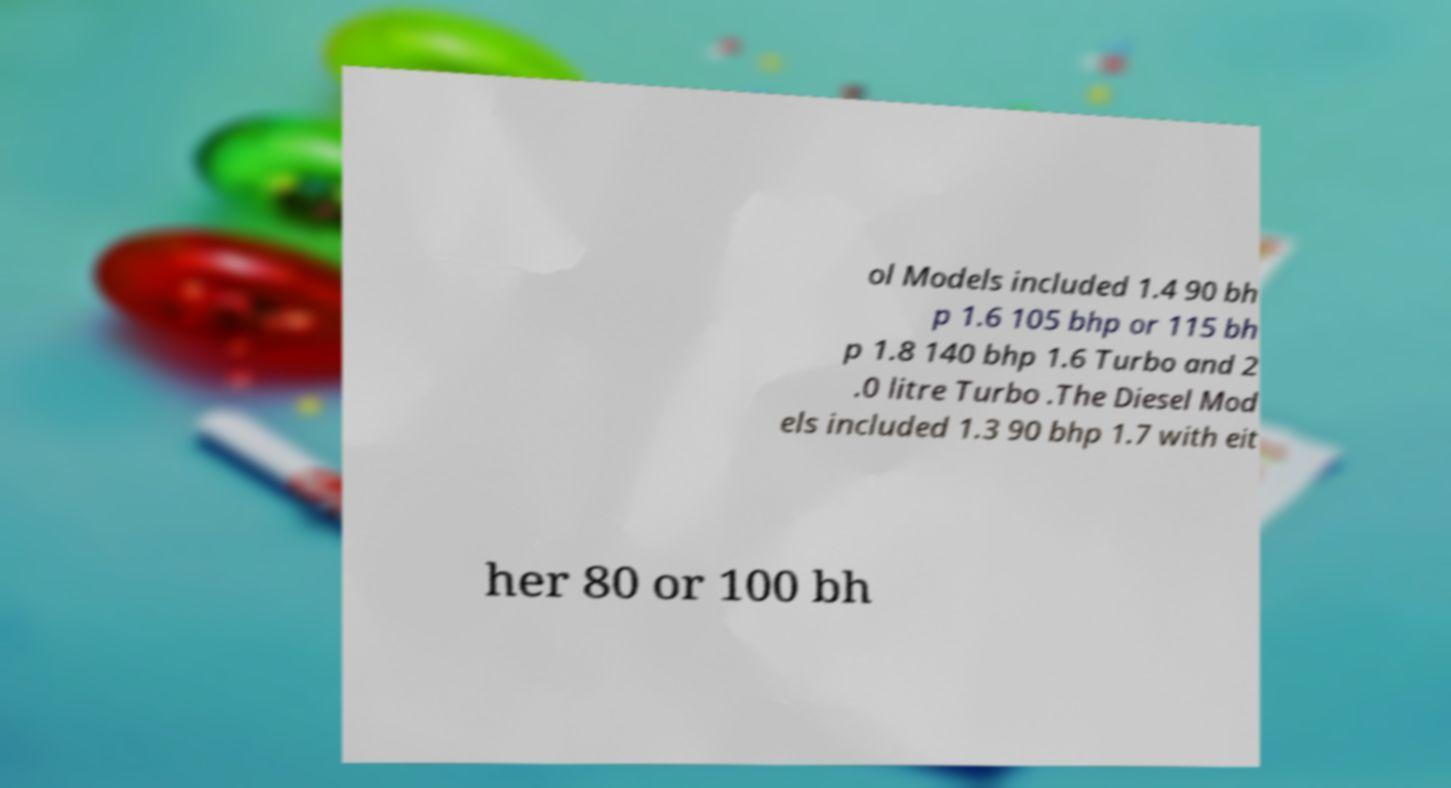There's text embedded in this image that I need extracted. Can you transcribe it verbatim? ol Models included 1.4 90 bh p 1.6 105 bhp or 115 bh p 1.8 140 bhp 1.6 Turbo and 2 .0 litre Turbo .The Diesel Mod els included 1.3 90 bhp 1.7 with eit her 80 or 100 bh 